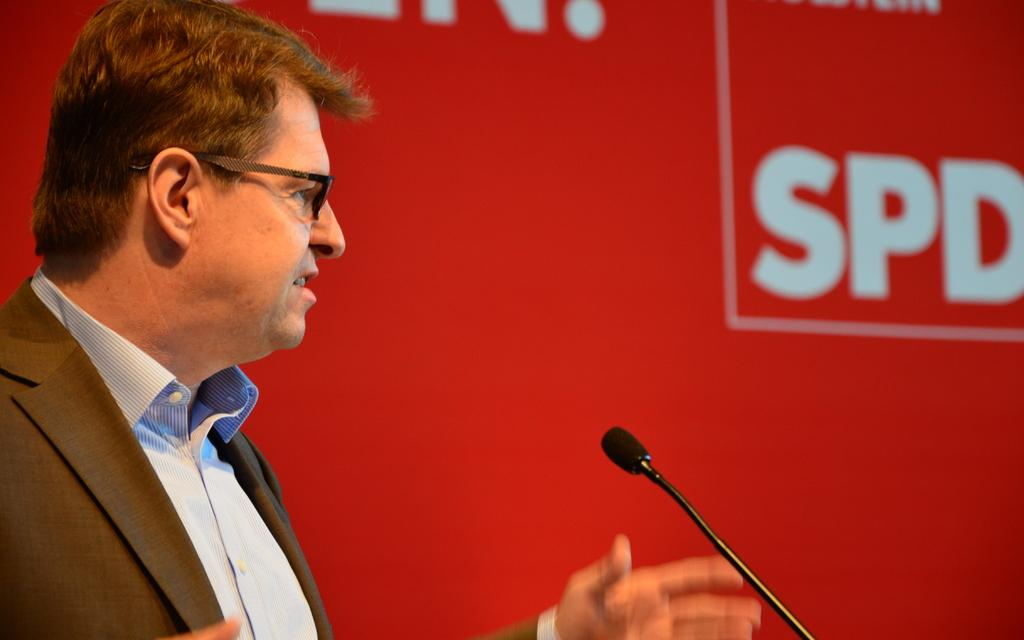What is the man in the image doing? The man is standing and talking in the image. What is behind the man in the image? There is a board at the back of the man. What can be seen on the board? There is text on the board. What object is on the right side of the image? There is a microphone on the right side of the image. Can you see any boxes being used for teaching in the image? There are no boxes present in the image, and teaching is not explicitly mentioned or depicted. 